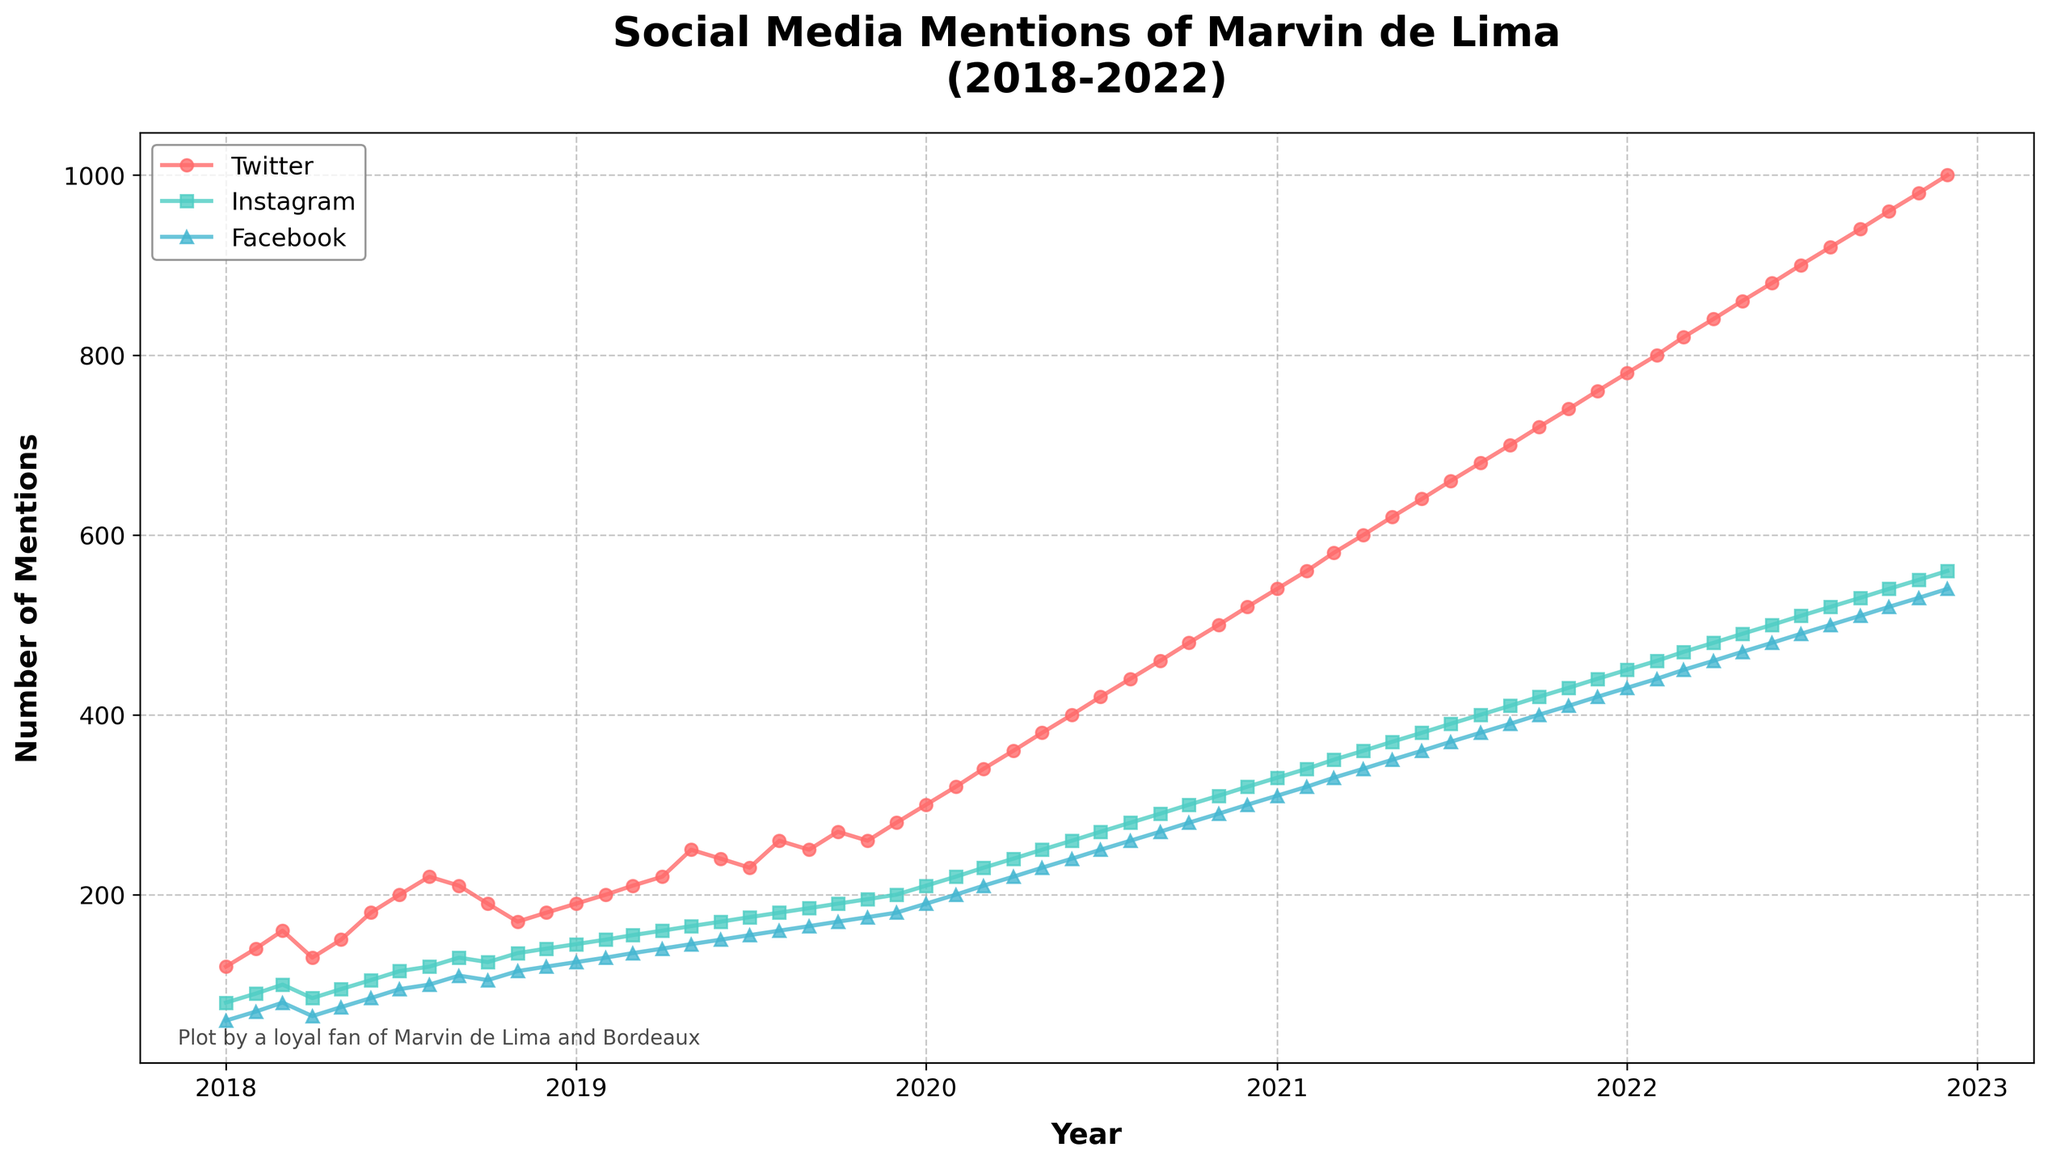Which social media platform has the most mentions for Marvin de Lima in December 2022? By looking at the end of the time series data, December 2022, compare the social media mentions for Twitter, Instagram, and Facebook. Twitter has the highest value at that point.
Answer: Twitter What is the trend of Marvin de Lima's mentions on Instagram from 2018 to 2022? Observe the plotted line for Instagram from the beginning to the end of the period. The trend is continuously rising, showing an increasing number of mentions each year.
Answer: Increasing How did Facebook mentions change from January 2020 to January 2021? Examine the Facebook line between January 2020 and January 2021. It starts at 190 in January 2020 and goes up steadily to 310 by January 2021.
Answer: Increased When did Twitter mentions reach 500 for the first time? Find the point on the Twitter line where it first hits 500. This occurs in November 2020.
Answer: November 2020 Which platform had the smallest number of mentions for Marvin de Lima in January 2018? Compare the mentions in January 2018 for Twitter, Instagram, and Facebook. Facebook has the smallest number of mentions at 60.
Answer: Facebook What's the average number of social media mentions for Marvin de Lima on Twitter in 2020? Calculate the average of the monthly mentions on Twitter for the year 2020, which starts at 300 in January and ends at 520 in December. The average is (300 + 320 + 340 + 360 + 380 + 400 + 420 + 440 + 460 + 480 + 500 + 520) / 12 = 410.
Answer: 410 Which month of 2021 had the highest number of mentions on Instagram? Look at each point for Instagram in 2021 and find the highest value, which is 440 in December.
Answer: December How many total mentions did Facebook have in 2018? Sum the monthly mentions for Facebook in 2018: 60 + 70 + 80 + 65 + 75 + 85 + 95 + 100 + 110 + 105 + 115 + 120 = 1080.
Answer: 1080 Which platform shows the steepest increase in mentions over the five years? Compare the slopes of the lines. Twitter has the steepest increase, going from 120 in January 2018 to 1000 in December 2022.
Answer: Twitter 